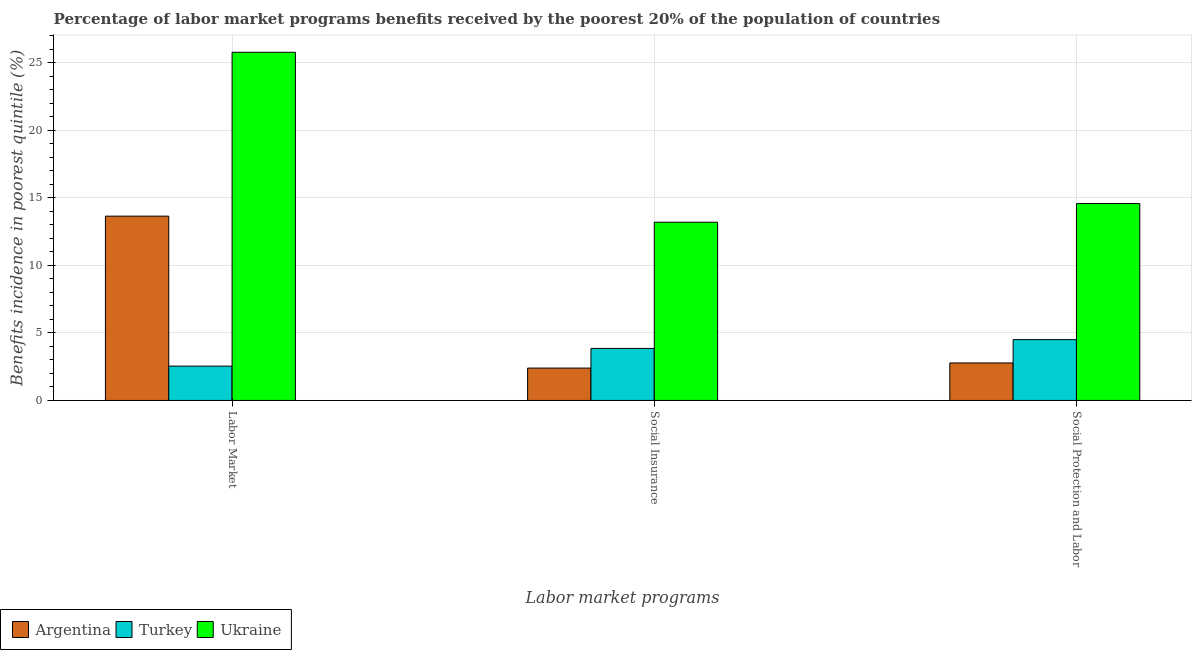How many different coloured bars are there?
Keep it short and to the point. 3. How many groups of bars are there?
Ensure brevity in your answer.  3. How many bars are there on the 1st tick from the left?
Your answer should be very brief. 3. What is the label of the 1st group of bars from the left?
Give a very brief answer. Labor Market. What is the percentage of benefits received due to social insurance programs in Ukraine?
Your response must be concise. 13.2. Across all countries, what is the maximum percentage of benefits received due to social protection programs?
Your answer should be compact. 14.59. Across all countries, what is the minimum percentage of benefits received due to social protection programs?
Give a very brief answer. 2.78. In which country was the percentage of benefits received due to labor market programs maximum?
Provide a short and direct response. Ukraine. In which country was the percentage of benefits received due to social protection programs minimum?
Keep it short and to the point. Argentina. What is the total percentage of benefits received due to social insurance programs in the graph?
Ensure brevity in your answer.  19.45. What is the difference between the percentage of benefits received due to social insurance programs in Argentina and that in Ukraine?
Offer a very short reply. -10.8. What is the difference between the percentage of benefits received due to social insurance programs in Turkey and the percentage of benefits received due to social protection programs in Argentina?
Make the answer very short. 1.08. What is the average percentage of benefits received due to social insurance programs per country?
Provide a short and direct response. 6.48. What is the difference between the percentage of benefits received due to labor market programs and percentage of benefits received due to social protection programs in Ukraine?
Ensure brevity in your answer.  11.21. What is the ratio of the percentage of benefits received due to social protection programs in Turkey to that in Argentina?
Your response must be concise. 1.62. Is the percentage of benefits received due to social protection programs in Ukraine less than that in Turkey?
Offer a terse response. No. Is the difference between the percentage of benefits received due to social protection programs in Ukraine and Turkey greater than the difference between the percentage of benefits received due to social insurance programs in Ukraine and Turkey?
Give a very brief answer. Yes. What is the difference between the highest and the second highest percentage of benefits received due to social protection programs?
Your response must be concise. 10.08. What is the difference between the highest and the lowest percentage of benefits received due to social insurance programs?
Offer a terse response. 10.8. What does the 3rd bar from the left in Social Protection and Labor represents?
Make the answer very short. Ukraine. Is it the case that in every country, the sum of the percentage of benefits received due to labor market programs and percentage of benefits received due to social insurance programs is greater than the percentage of benefits received due to social protection programs?
Your answer should be compact. Yes. How many bars are there?
Give a very brief answer. 9. Are all the bars in the graph horizontal?
Make the answer very short. No. Are the values on the major ticks of Y-axis written in scientific E-notation?
Your answer should be compact. No. Does the graph contain any zero values?
Your response must be concise. No. What is the title of the graph?
Ensure brevity in your answer.  Percentage of labor market programs benefits received by the poorest 20% of the population of countries. What is the label or title of the X-axis?
Ensure brevity in your answer.  Labor market programs. What is the label or title of the Y-axis?
Give a very brief answer. Benefits incidence in poorest quintile (%). What is the Benefits incidence in poorest quintile (%) of Argentina in Labor Market?
Offer a very short reply. 13.65. What is the Benefits incidence in poorest quintile (%) of Turkey in Labor Market?
Offer a very short reply. 2.54. What is the Benefits incidence in poorest quintile (%) in Ukraine in Labor Market?
Offer a terse response. 25.79. What is the Benefits incidence in poorest quintile (%) in Argentina in Social Insurance?
Your answer should be very brief. 2.4. What is the Benefits incidence in poorest quintile (%) in Turkey in Social Insurance?
Offer a terse response. 3.85. What is the Benefits incidence in poorest quintile (%) of Ukraine in Social Insurance?
Your answer should be compact. 13.2. What is the Benefits incidence in poorest quintile (%) in Argentina in Social Protection and Labor?
Your answer should be compact. 2.78. What is the Benefits incidence in poorest quintile (%) of Turkey in Social Protection and Labor?
Give a very brief answer. 4.5. What is the Benefits incidence in poorest quintile (%) in Ukraine in Social Protection and Labor?
Your answer should be compact. 14.59. Across all Labor market programs, what is the maximum Benefits incidence in poorest quintile (%) in Argentina?
Offer a terse response. 13.65. Across all Labor market programs, what is the maximum Benefits incidence in poorest quintile (%) of Turkey?
Provide a short and direct response. 4.5. Across all Labor market programs, what is the maximum Benefits incidence in poorest quintile (%) in Ukraine?
Offer a terse response. 25.79. Across all Labor market programs, what is the minimum Benefits incidence in poorest quintile (%) in Argentina?
Ensure brevity in your answer.  2.4. Across all Labor market programs, what is the minimum Benefits incidence in poorest quintile (%) of Turkey?
Offer a terse response. 2.54. Across all Labor market programs, what is the minimum Benefits incidence in poorest quintile (%) in Ukraine?
Your answer should be compact. 13.2. What is the total Benefits incidence in poorest quintile (%) in Argentina in the graph?
Your answer should be compact. 18.83. What is the total Benefits incidence in poorest quintile (%) of Turkey in the graph?
Make the answer very short. 10.9. What is the total Benefits incidence in poorest quintile (%) of Ukraine in the graph?
Your answer should be compact. 53.58. What is the difference between the Benefits incidence in poorest quintile (%) of Argentina in Labor Market and that in Social Insurance?
Provide a short and direct response. 11.25. What is the difference between the Benefits incidence in poorest quintile (%) in Turkey in Labor Market and that in Social Insurance?
Offer a very short reply. -1.31. What is the difference between the Benefits incidence in poorest quintile (%) in Ukraine in Labor Market and that in Social Insurance?
Offer a very short reply. 12.59. What is the difference between the Benefits incidence in poorest quintile (%) in Argentina in Labor Market and that in Social Protection and Labor?
Offer a terse response. 10.88. What is the difference between the Benefits incidence in poorest quintile (%) in Turkey in Labor Market and that in Social Protection and Labor?
Your answer should be very brief. -1.96. What is the difference between the Benefits incidence in poorest quintile (%) in Ukraine in Labor Market and that in Social Protection and Labor?
Keep it short and to the point. 11.21. What is the difference between the Benefits incidence in poorest quintile (%) in Argentina in Social Insurance and that in Social Protection and Labor?
Offer a terse response. -0.38. What is the difference between the Benefits incidence in poorest quintile (%) in Turkey in Social Insurance and that in Social Protection and Labor?
Offer a terse response. -0.65. What is the difference between the Benefits incidence in poorest quintile (%) of Ukraine in Social Insurance and that in Social Protection and Labor?
Keep it short and to the point. -1.38. What is the difference between the Benefits incidence in poorest quintile (%) of Argentina in Labor Market and the Benefits incidence in poorest quintile (%) of Turkey in Social Insurance?
Your response must be concise. 9.8. What is the difference between the Benefits incidence in poorest quintile (%) of Argentina in Labor Market and the Benefits incidence in poorest quintile (%) of Ukraine in Social Insurance?
Your answer should be very brief. 0.45. What is the difference between the Benefits incidence in poorest quintile (%) of Turkey in Labor Market and the Benefits incidence in poorest quintile (%) of Ukraine in Social Insurance?
Your response must be concise. -10.66. What is the difference between the Benefits incidence in poorest quintile (%) in Argentina in Labor Market and the Benefits incidence in poorest quintile (%) in Turkey in Social Protection and Labor?
Your response must be concise. 9.15. What is the difference between the Benefits incidence in poorest quintile (%) in Argentina in Labor Market and the Benefits incidence in poorest quintile (%) in Ukraine in Social Protection and Labor?
Give a very brief answer. -0.93. What is the difference between the Benefits incidence in poorest quintile (%) of Turkey in Labor Market and the Benefits incidence in poorest quintile (%) of Ukraine in Social Protection and Labor?
Your response must be concise. -12.04. What is the difference between the Benefits incidence in poorest quintile (%) of Argentina in Social Insurance and the Benefits incidence in poorest quintile (%) of Turkey in Social Protection and Labor?
Keep it short and to the point. -2.1. What is the difference between the Benefits incidence in poorest quintile (%) of Argentina in Social Insurance and the Benefits incidence in poorest quintile (%) of Ukraine in Social Protection and Labor?
Provide a short and direct response. -12.19. What is the difference between the Benefits incidence in poorest quintile (%) in Turkey in Social Insurance and the Benefits incidence in poorest quintile (%) in Ukraine in Social Protection and Labor?
Provide a short and direct response. -10.73. What is the average Benefits incidence in poorest quintile (%) of Argentina per Labor market programs?
Offer a terse response. 6.28. What is the average Benefits incidence in poorest quintile (%) of Turkey per Labor market programs?
Keep it short and to the point. 3.63. What is the average Benefits incidence in poorest quintile (%) of Ukraine per Labor market programs?
Ensure brevity in your answer.  17.86. What is the difference between the Benefits incidence in poorest quintile (%) in Argentina and Benefits incidence in poorest quintile (%) in Turkey in Labor Market?
Offer a very short reply. 11.11. What is the difference between the Benefits incidence in poorest quintile (%) of Argentina and Benefits incidence in poorest quintile (%) of Ukraine in Labor Market?
Make the answer very short. -12.14. What is the difference between the Benefits incidence in poorest quintile (%) in Turkey and Benefits incidence in poorest quintile (%) in Ukraine in Labor Market?
Give a very brief answer. -23.25. What is the difference between the Benefits incidence in poorest quintile (%) in Argentina and Benefits incidence in poorest quintile (%) in Turkey in Social Insurance?
Your answer should be compact. -1.45. What is the difference between the Benefits incidence in poorest quintile (%) in Argentina and Benefits incidence in poorest quintile (%) in Ukraine in Social Insurance?
Provide a short and direct response. -10.8. What is the difference between the Benefits incidence in poorest quintile (%) in Turkey and Benefits incidence in poorest quintile (%) in Ukraine in Social Insurance?
Offer a terse response. -9.35. What is the difference between the Benefits incidence in poorest quintile (%) in Argentina and Benefits incidence in poorest quintile (%) in Turkey in Social Protection and Labor?
Offer a very short reply. -1.73. What is the difference between the Benefits incidence in poorest quintile (%) in Argentina and Benefits incidence in poorest quintile (%) in Ukraine in Social Protection and Labor?
Ensure brevity in your answer.  -11.81. What is the difference between the Benefits incidence in poorest quintile (%) in Turkey and Benefits incidence in poorest quintile (%) in Ukraine in Social Protection and Labor?
Give a very brief answer. -10.08. What is the ratio of the Benefits incidence in poorest quintile (%) of Argentina in Labor Market to that in Social Insurance?
Your response must be concise. 5.69. What is the ratio of the Benefits incidence in poorest quintile (%) of Turkey in Labor Market to that in Social Insurance?
Your response must be concise. 0.66. What is the ratio of the Benefits incidence in poorest quintile (%) of Ukraine in Labor Market to that in Social Insurance?
Make the answer very short. 1.95. What is the ratio of the Benefits incidence in poorest quintile (%) of Argentina in Labor Market to that in Social Protection and Labor?
Give a very brief answer. 4.92. What is the ratio of the Benefits incidence in poorest quintile (%) of Turkey in Labor Market to that in Social Protection and Labor?
Offer a very short reply. 0.56. What is the ratio of the Benefits incidence in poorest quintile (%) in Ukraine in Labor Market to that in Social Protection and Labor?
Make the answer very short. 1.77. What is the ratio of the Benefits incidence in poorest quintile (%) in Argentina in Social Insurance to that in Social Protection and Labor?
Ensure brevity in your answer.  0.86. What is the ratio of the Benefits incidence in poorest quintile (%) in Turkey in Social Insurance to that in Social Protection and Labor?
Offer a very short reply. 0.86. What is the ratio of the Benefits incidence in poorest quintile (%) in Ukraine in Social Insurance to that in Social Protection and Labor?
Provide a short and direct response. 0.91. What is the difference between the highest and the second highest Benefits incidence in poorest quintile (%) of Argentina?
Your response must be concise. 10.88. What is the difference between the highest and the second highest Benefits incidence in poorest quintile (%) of Turkey?
Keep it short and to the point. 0.65. What is the difference between the highest and the second highest Benefits incidence in poorest quintile (%) of Ukraine?
Your answer should be compact. 11.21. What is the difference between the highest and the lowest Benefits incidence in poorest quintile (%) of Argentina?
Your answer should be very brief. 11.25. What is the difference between the highest and the lowest Benefits incidence in poorest quintile (%) of Turkey?
Offer a very short reply. 1.96. What is the difference between the highest and the lowest Benefits incidence in poorest quintile (%) in Ukraine?
Your response must be concise. 12.59. 